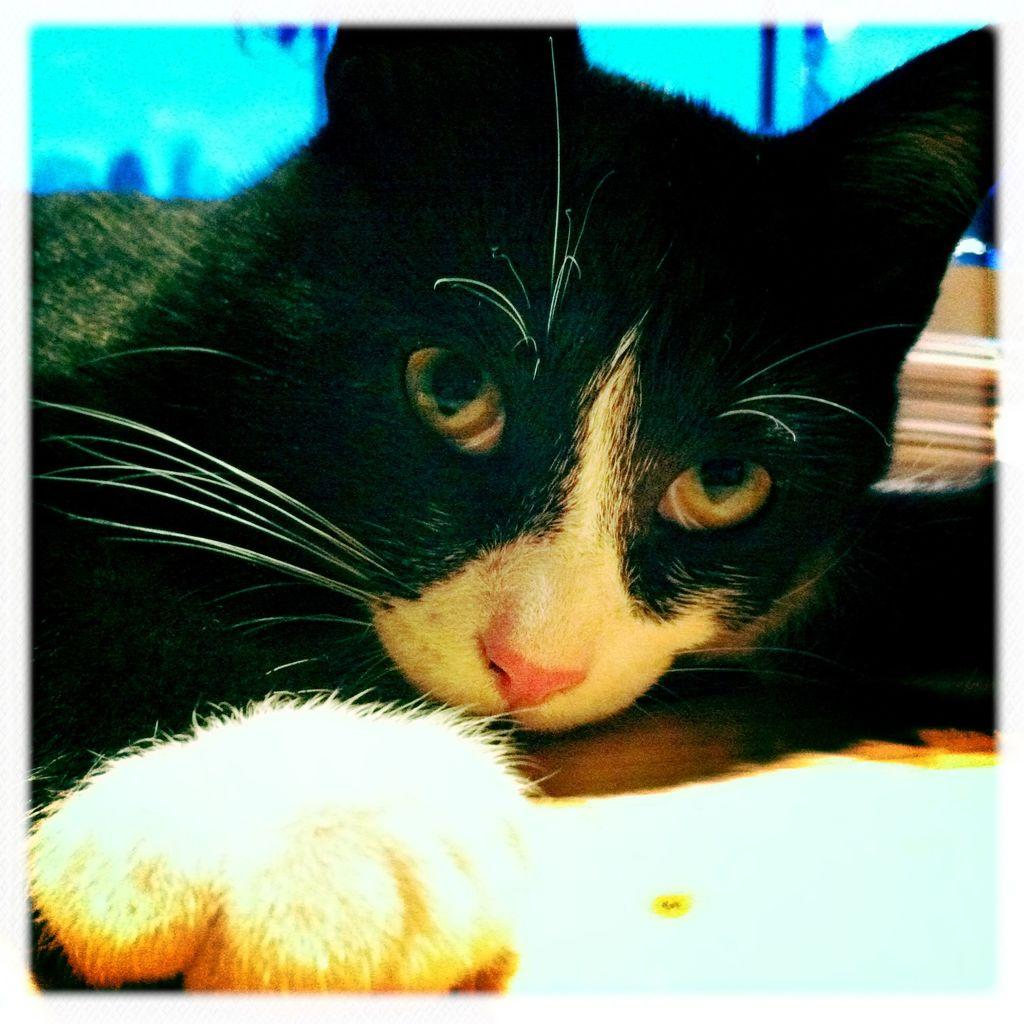What type of animal is in the picture? There is a cat in the picture. Can you describe the background of the picture? There are objects in the background of the picture. What type of lipstick is the cat wearing in the picture? There is no lipstick or any indication of makeup on the cat in the image. 